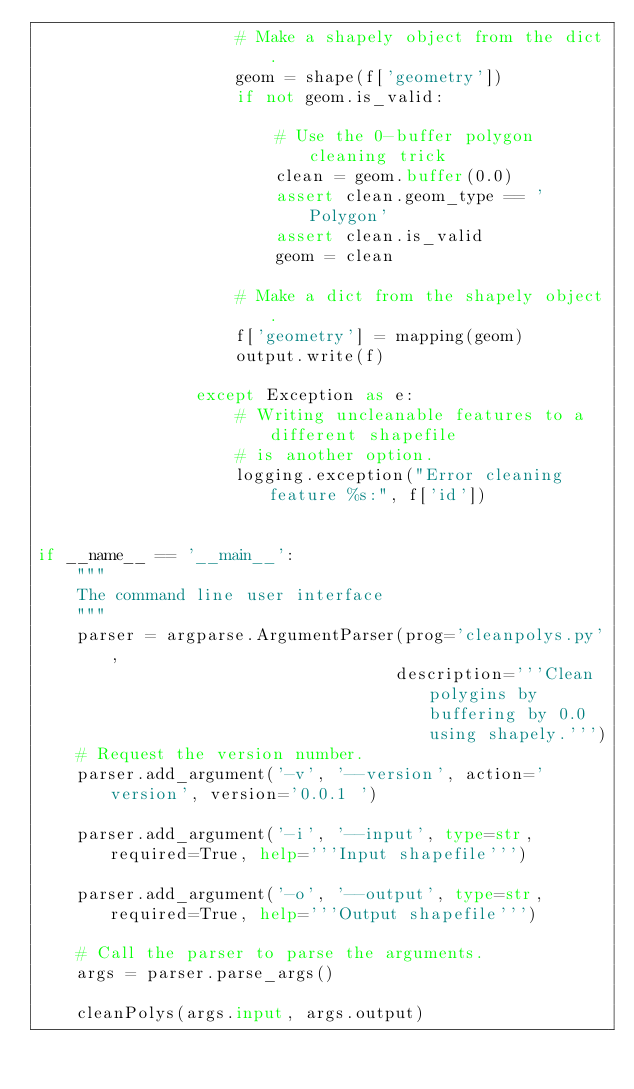Convert code to text. <code><loc_0><loc_0><loc_500><loc_500><_Python_>                    # Make a shapely object from the dict.
                    geom = shape(f['geometry'])
                    if not geom.is_valid:
    
                        # Use the 0-buffer polygon cleaning trick
                        clean = geom.buffer(0.0)
                        assert clean.geom_type == 'Polygon'
                        assert clean.is_valid
                        geom = clean
    
                    # Make a dict from the shapely object.
                    f['geometry'] = mapping(geom)
                    output.write(f)
    
                except Exception as e:
                    # Writing uncleanable features to a different shapefile
                    # is another option.
                    logging.exception("Error cleaning feature %s:", f['id'])
                
                
if __name__ == '__main__':
    """
    The command line user interface
    """
    parser = argparse.ArgumentParser(prog='cleanpolys.py',
                                    description='''Clean polygins by buffering by 0.0 using shapely.''')
    # Request the version number.
    parser.add_argument('-v', '--version', action='version', version='0.0.1 ')
    
    parser.add_argument('-i', '--input', type=str, required=True, help='''Input shapefile''')
    
    parser.add_argument('-o', '--output', type=str, required=True, help='''Output shapefile''')
    
    # Call the parser to parse the arguments.
    args = parser.parse_args()
    
    cleanPolys(args.input, args.output)
    </code> 